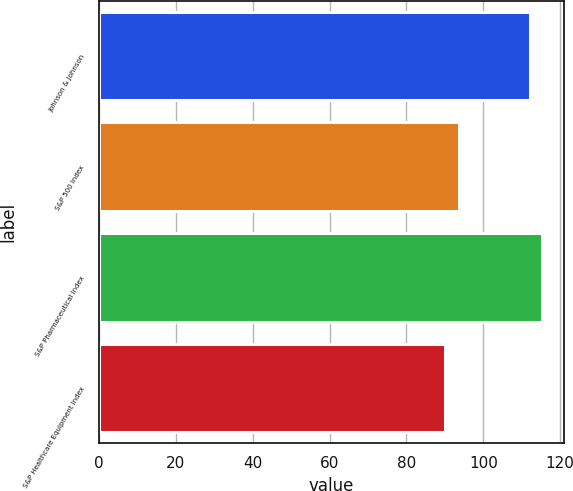Convert chart to OTSL. <chart><loc_0><loc_0><loc_500><loc_500><bar_chart><fcel>Johnson & Johnson<fcel>S&P 500 Index<fcel>S&P Pharmaceutical Index<fcel>S&P Healthcare Equipment Index<nl><fcel>112.13<fcel>93.59<fcel>115.15<fcel>89.94<nl></chart> 